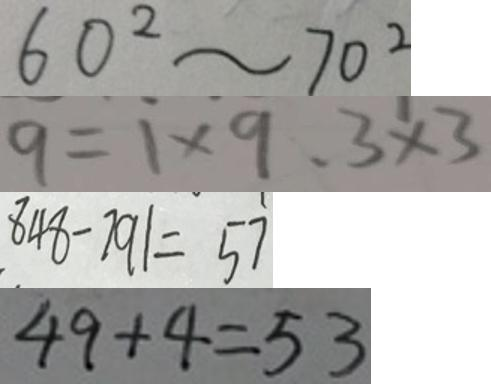Convert formula to latex. <formula><loc_0><loc_0><loc_500><loc_500>6 0 ^ { 2 } \sim 7 0 ^ { 2 } 
 9 = 1 \times 9 . 3 \times 3 
 8 4 8 - 7 9 1 = 5 7 
 4 9 + 4 = 5 3</formula> 